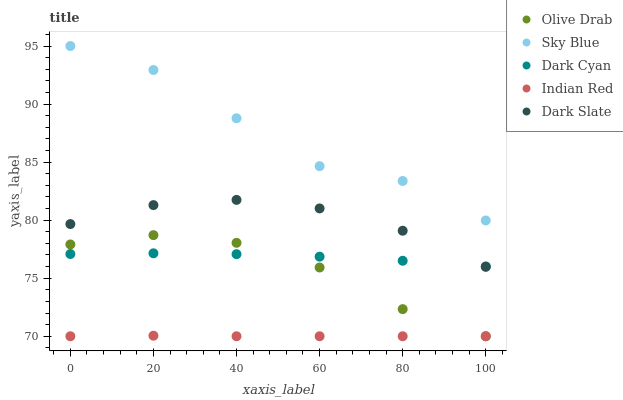Does Indian Red have the minimum area under the curve?
Answer yes or no. Yes. Does Sky Blue have the maximum area under the curve?
Answer yes or no. Yes. Does Sky Blue have the minimum area under the curve?
Answer yes or no. No. Does Indian Red have the maximum area under the curve?
Answer yes or no. No. Is Indian Red the smoothest?
Answer yes or no. Yes. Is Sky Blue the roughest?
Answer yes or no. Yes. Is Sky Blue the smoothest?
Answer yes or no. No. Is Indian Red the roughest?
Answer yes or no. No. Does Indian Red have the lowest value?
Answer yes or no. Yes. Does Sky Blue have the lowest value?
Answer yes or no. No. Does Sky Blue have the highest value?
Answer yes or no. Yes. Does Indian Red have the highest value?
Answer yes or no. No. Is Indian Red less than Dark Cyan?
Answer yes or no. Yes. Is Sky Blue greater than Dark Slate?
Answer yes or no. Yes. Does Dark Cyan intersect Olive Drab?
Answer yes or no. Yes. Is Dark Cyan less than Olive Drab?
Answer yes or no. No. Is Dark Cyan greater than Olive Drab?
Answer yes or no. No. Does Indian Red intersect Dark Cyan?
Answer yes or no. No. 